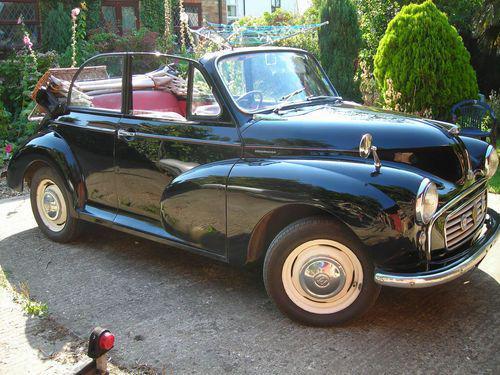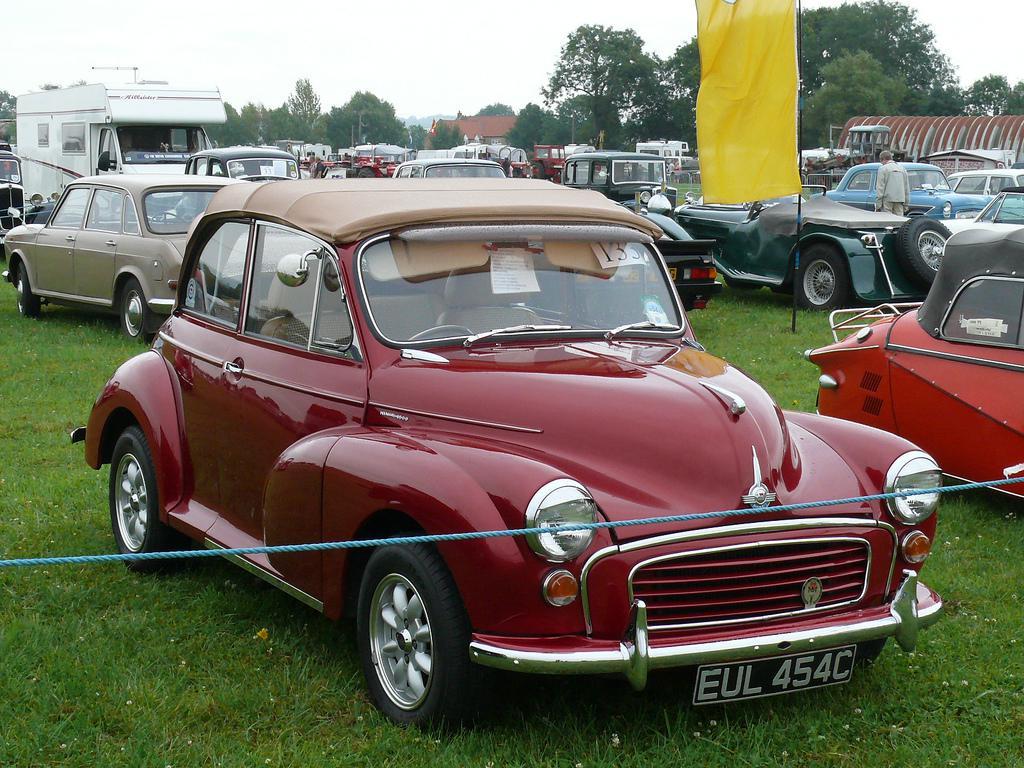The first image is the image on the left, the second image is the image on the right. Assess this claim about the two images: "There is a blue car and a green car". Correct or not? Answer yes or no. No. 